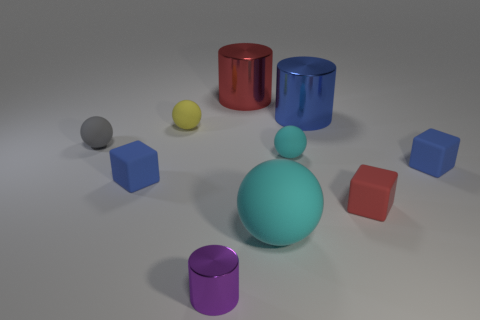Subtract all green spheres. Subtract all purple cylinders. How many spheres are left? 4 Subtract all cylinders. How many objects are left? 7 Add 6 matte spheres. How many matte spheres are left? 10 Add 7 blue rubber things. How many blue rubber things exist? 9 Subtract 0 purple cubes. How many objects are left? 10 Subtract all large red cylinders. Subtract all blue blocks. How many objects are left? 7 